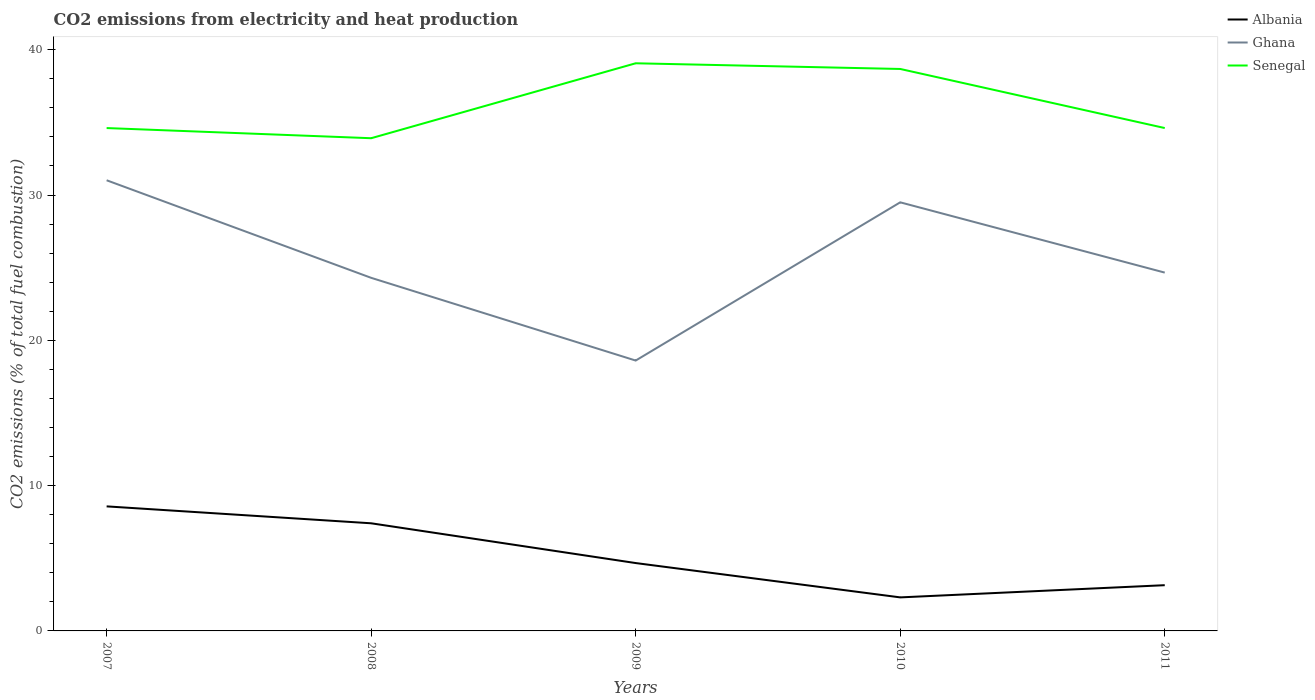How many different coloured lines are there?
Give a very brief answer. 3. Does the line corresponding to Ghana intersect with the line corresponding to Albania?
Give a very brief answer. No. Across all years, what is the maximum amount of CO2 emitted in Albania?
Your response must be concise. 2.31. In which year was the amount of CO2 emitted in Ghana maximum?
Keep it short and to the point. 2009. What is the total amount of CO2 emitted in Ghana in the graph?
Offer a terse response. -6.05. What is the difference between the highest and the second highest amount of CO2 emitted in Albania?
Make the answer very short. 6.26. Is the amount of CO2 emitted in Albania strictly greater than the amount of CO2 emitted in Ghana over the years?
Your answer should be very brief. Yes. What is the difference between two consecutive major ticks on the Y-axis?
Your answer should be very brief. 10. Are the values on the major ticks of Y-axis written in scientific E-notation?
Your answer should be very brief. No. Does the graph contain any zero values?
Your answer should be compact. No. Where does the legend appear in the graph?
Your answer should be very brief. Top right. How are the legend labels stacked?
Make the answer very short. Vertical. What is the title of the graph?
Your answer should be compact. CO2 emissions from electricity and heat production. What is the label or title of the X-axis?
Your answer should be compact. Years. What is the label or title of the Y-axis?
Your answer should be compact. CO2 emissions (% of total fuel combustion). What is the CO2 emissions (% of total fuel combustion) in Albania in 2007?
Ensure brevity in your answer.  8.57. What is the CO2 emissions (% of total fuel combustion) of Ghana in 2007?
Your response must be concise. 31.01. What is the CO2 emissions (% of total fuel combustion) in Senegal in 2007?
Provide a short and direct response. 34.61. What is the CO2 emissions (% of total fuel combustion) in Albania in 2008?
Make the answer very short. 7.41. What is the CO2 emissions (% of total fuel combustion) in Ghana in 2008?
Provide a short and direct response. 24.3. What is the CO2 emissions (% of total fuel combustion) in Senegal in 2008?
Your answer should be very brief. 33.91. What is the CO2 emissions (% of total fuel combustion) of Albania in 2009?
Your answer should be compact. 4.67. What is the CO2 emissions (% of total fuel combustion) in Ghana in 2009?
Provide a succinct answer. 18.61. What is the CO2 emissions (% of total fuel combustion) of Senegal in 2009?
Provide a short and direct response. 39.07. What is the CO2 emissions (% of total fuel combustion) of Albania in 2010?
Your response must be concise. 2.31. What is the CO2 emissions (% of total fuel combustion) in Ghana in 2010?
Make the answer very short. 29.5. What is the CO2 emissions (% of total fuel combustion) in Senegal in 2010?
Ensure brevity in your answer.  38.67. What is the CO2 emissions (% of total fuel combustion) of Albania in 2011?
Make the answer very short. 3.15. What is the CO2 emissions (% of total fuel combustion) in Ghana in 2011?
Give a very brief answer. 24.66. What is the CO2 emissions (% of total fuel combustion) of Senegal in 2011?
Make the answer very short. 34.61. Across all years, what is the maximum CO2 emissions (% of total fuel combustion) of Albania?
Your answer should be very brief. 8.57. Across all years, what is the maximum CO2 emissions (% of total fuel combustion) of Ghana?
Your response must be concise. 31.01. Across all years, what is the maximum CO2 emissions (% of total fuel combustion) of Senegal?
Your response must be concise. 39.07. Across all years, what is the minimum CO2 emissions (% of total fuel combustion) of Albania?
Your response must be concise. 2.31. Across all years, what is the minimum CO2 emissions (% of total fuel combustion) in Ghana?
Give a very brief answer. 18.61. Across all years, what is the minimum CO2 emissions (% of total fuel combustion) of Senegal?
Your response must be concise. 33.91. What is the total CO2 emissions (% of total fuel combustion) of Albania in the graph?
Ensure brevity in your answer.  26.1. What is the total CO2 emissions (% of total fuel combustion) of Ghana in the graph?
Keep it short and to the point. 128.08. What is the total CO2 emissions (% of total fuel combustion) of Senegal in the graph?
Offer a very short reply. 180.86. What is the difference between the CO2 emissions (% of total fuel combustion) of Albania in 2007 and that in 2008?
Offer a terse response. 1.16. What is the difference between the CO2 emissions (% of total fuel combustion) of Ghana in 2007 and that in 2008?
Offer a very short reply. 6.71. What is the difference between the CO2 emissions (% of total fuel combustion) in Senegal in 2007 and that in 2008?
Provide a succinct answer. 0.7. What is the difference between the CO2 emissions (% of total fuel combustion) in Albania in 2007 and that in 2009?
Make the answer very short. 3.9. What is the difference between the CO2 emissions (% of total fuel combustion) in Ghana in 2007 and that in 2009?
Provide a succinct answer. 12.41. What is the difference between the CO2 emissions (% of total fuel combustion) in Senegal in 2007 and that in 2009?
Give a very brief answer. -4.46. What is the difference between the CO2 emissions (% of total fuel combustion) of Albania in 2007 and that in 2010?
Keep it short and to the point. 6.26. What is the difference between the CO2 emissions (% of total fuel combustion) in Ghana in 2007 and that in 2010?
Your response must be concise. 1.52. What is the difference between the CO2 emissions (% of total fuel combustion) of Senegal in 2007 and that in 2010?
Provide a succinct answer. -4.07. What is the difference between the CO2 emissions (% of total fuel combustion) of Albania in 2007 and that in 2011?
Give a very brief answer. 5.42. What is the difference between the CO2 emissions (% of total fuel combustion) of Ghana in 2007 and that in 2011?
Your response must be concise. 6.35. What is the difference between the CO2 emissions (% of total fuel combustion) in Senegal in 2007 and that in 2011?
Offer a very short reply. -0. What is the difference between the CO2 emissions (% of total fuel combustion) of Albania in 2008 and that in 2009?
Your response must be concise. 2.74. What is the difference between the CO2 emissions (% of total fuel combustion) of Ghana in 2008 and that in 2009?
Give a very brief answer. 5.69. What is the difference between the CO2 emissions (% of total fuel combustion) of Senegal in 2008 and that in 2009?
Provide a short and direct response. -5.16. What is the difference between the CO2 emissions (% of total fuel combustion) of Albania in 2008 and that in 2010?
Offer a terse response. 5.1. What is the difference between the CO2 emissions (% of total fuel combustion) of Ghana in 2008 and that in 2010?
Provide a short and direct response. -5.2. What is the difference between the CO2 emissions (% of total fuel combustion) in Senegal in 2008 and that in 2010?
Offer a terse response. -4.77. What is the difference between the CO2 emissions (% of total fuel combustion) of Albania in 2008 and that in 2011?
Provide a succinct answer. 4.26. What is the difference between the CO2 emissions (% of total fuel combustion) of Ghana in 2008 and that in 2011?
Make the answer very short. -0.36. What is the difference between the CO2 emissions (% of total fuel combustion) in Senegal in 2008 and that in 2011?
Make the answer very short. -0.7. What is the difference between the CO2 emissions (% of total fuel combustion) of Albania in 2009 and that in 2010?
Ensure brevity in your answer.  2.36. What is the difference between the CO2 emissions (% of total fuel combustion) of Ghana in 2009 and that in 2010?
Your answer should be very brief. -10.89. What is the difference between the CO2 emissions (% of total fuel combustion) in Senegal in 2009 and that in 2010?
Give a very brief answer. 0.39. What is the difference between the CO2 emissions (% of total fuel combustion) in Albania in 2009 and that in 2011?
Ensure brevity in your answer.  1.52. What is the difference between the CO2 emissions (% of total fuel combustion) in Ghana in 2009 and that in 2011?
Provide a short and direct response. -6.05. What is the difference between the CO2 emissions (% of total fuel combustion) in Senegal in 2009 and that in 2011?
Offer a very short reply. 4.46. What is the difference between the CO2 emissions (% of total fuel combustion) in Albania in 2010 and that in 2011?
Offer a very short reply. -0.84. What is the difference between the CO2 emissions (% of total fuel combustion) in Ghana in 2010 and that in 2011?
Your response must be concise. 4.84. What is the difference between the CO2 emissions (% of total fuel combustion) of Senegal in 2010 and that in 2011?
Make the answer very short. 4.07. What is the difference between the CO2 emissions (% of total fuel combustion) of Albania in 2007 and the CO2 emissions (% of total fuel combustion) of Ghana in 2008?
Offer a very short reply. -15.73. What is the difference between the CO2 emissions (% of total fuel combustion) in Albania in 2007 and the CO2 emissions (% of total fuel combustion) in Senegal in 2008?
Offer a terse response. -25.34. What is the difference between the CO2 emissions (% of total fuel combustion) of Ghana in 2007 and the CO2 emissions (% of total fuel combustion) of Senegal in 2008?
Make the answer very short. -2.89. What is the difference between the CO2 emissions (% of total fuel combustion) in Albania in 2007 and the CO2 emissions (% of total fuel combustion) in Ghana in 2009?
Give a very brief answer. -10.04. What is the difference between the CO2 emissions (% of total fuel combustion) in Albania in 2007 and the CO2 emissions (% of total fuel combustion) in Senegal in 2009?
Give a very brief answer. -30.49. What is the difference between the CO2 emissions (% of total fuel combustion) of Ghana in 2007 and the CO2 emissions (% of total fuel combustion) of Senegal in 2009?
Keep it short and to the point. -8.05. What is the difference between the CO2 emissions (% of total fuel combustion) of Albania in 2007 and the CO2 emissions (% of total fuel combustion) of Ghana in 2010?
Your answer should be very brief. -20.92. What is the difference between the CO2 emissions (% of total fuel combustion) of Albania in 2007 and the CO2 emissions (% of total fuel combustion) of Senegal in 2010?
Your response must be concise. -30.1. What is the difference between the CO2 emissions (% of total fuel combustion) in Ghana in 2007 and the CO2 emissions (% of total fuel combustion) in Senegal in 2010?
Give a very brief answer. -7.66. What is the difference between the CO2 emissions (% of total fuel combustion) of Albania in 2007 and the CO2 emissions (% of total fuel combustion) of Ghana in 2011?
Provide a short and direct response. -16.09. What is the difference between the CO2 emissions (% of total fuel combustion) of Albania in 2007 and the CO2 emissions (% of total fuel combustion) of Senegal in 2011?
Offer a terse response. -26.04. What is the difference between the CO2 emissions (% of total fuel combustion) of Ghana in 2007 and the CO2 emissions (% of total fuel combustion) of Senegal in 2011?
Offer a terse response. -3.59. What is the difference between the CO2 emissions (% of total fuel combustion) in Albania in 2008 and the CO2 emissions (% of total fuel combustion) in Ghana in 2009?
Give a very brief answer. -11.2. What is the difference between the CO2 emissions (% of total fuel combustion) of Albania in 2008 and the CO2 emissions (% of total fuel combustion) of Senegal in 2009?
Offer a very short reply. -31.66. What is the difference between the CO2 emissions (% of total fuel combustion) of Ghana in 2008 and the CO2 emissions (% of total fuel combustion) of Senegal in 2009?
Your answer should be compact. -14.77. What is the difference between the CO2 emissions (% of total fuel combustion) in Albania in 2008 and the CO2 emissions (% of total fuel combustion) in Ghana in 2010?
Keep it short and to the point. -22.09. What is the difference between the CO2 emissions (% of total fuel combustion) of Albania in 2008 and the CO2 emissions (% of total fuel combustion) of Senegal in 2010?
Give a very brief answer. -31.27. What is the difference between the CO2 emissions (% of total fuel combustion) in Ghana in 2008 and the CO2 emissions (% of total fuel combustion) in Senegal in 2010?
Ensure brevity in your answer.  -14.37. What is the difference between the CO2 emissions (% of total fuel combustion) in Albania in 2008 and the CO2 emissions (% of total fuel combustion) in Ghana in 2011?
Make the answer very short. -17.25. What is the difference between the CO2 emissions (% of total fuel combustion) in Albania in 2008 and the CO2 emissions (% of total fuel combustion) in Senegal in 2011?
Give a very brief answer. -27.2. What is the difference between the CO2 emissions (% of total fuel combustion) of Ghana in 2008 and the CO2 emissions (% of total fuel combustion) of Senegal in 2011?
Provide a succinct answer. -10.31. What is the difference between the CO2 emissions (% of total fuel combustion) of Albania in 2009 and the CO2 emissions (% of total fuel combustion) of Ghana in 2010?
Your response must be concise. -24.83. What is the difference between the CO2 emissions (% of total fuel combustion) in Albania in 2009 and the CO2 emissions (% of total fuel combustion) in Senegal in 2010?
Keep it short and to the point. -34. What is the difference between the CO2 emissions (% of total fuel combustion) in Ghana in 2009 and the CO2 emissions (% of total fuel combustion) in Senegal in 2010?
Offer a terse response. -20.07. What is the difference between the CO2 emissions (% of total fuel combustion) of Albania in 2009 and the CO2 emissions (% of total fuel combustion) of Ghana in 2011?
Offer a very short reply. -19.99. What is the difference between the CO2 emissions (% of total fuel combustion) of Albania in 2009 and the CO2 emissions (% of total fuel combustion) of Senegal in 2011?
Give a very brief answer. -29.94. What is the difference between the CO2 emissions (% of total fuel combustion) in Ghana in 2009 and the CO2 emissions (% of total fuel combustion) in Senegal in 2011?
Offer a terse response. -16. What is the difference between the CO2 emissions (% of total fuel combustion) of Albania in 2010 and the CO2 emissions (% of total fuel combustion) of Ghana in 2011?
Your answer should be compact. -22.35. What is the difference between the CO2 emissions (% of total fuel combustion) of Albania in 2010 and the CO2 emissions (% of total fuel combustion) of Senegal in 2011?
Offer a terse response. -32.3. What is the difference between the CO2 emissions (% of total fuel combustion) in Ghana in 2010 and the CO2 emissions (% of total fuel combustion) in Senegal in 2011?
Provide a short and direct response. -5.11. What is the average CO2 emissions (% of total fuel combustion) of Albania per year?
Your answer should be very brief. 5.22. What is the average CO2 emissions (% of total fuel combustion) in Ghana per year?
Your answer should be compact. 25.62. What is the average CO2 emissions (% of total fuel combustion) in Senegal per year?
Provide a short and direct response. 36.17. In the year 2007, what is the difference between the CO2 emissions (% of total fuel combustion) in Albania and CO2 emissions (% of total fuel combustion) in Ghana?
Provide a short and direct response. -22.44. In the year 2007, what is the difference between the CO2 emissions (% of total fuel combustion) of Albania and CO2 emissions (% of total fuel combustion) of Senegal?
Offer a very short reply. -26.04. In the year 2007, what is the difference between the CO2 emissions (% of total fuel combustion) in Ghana and CO2 emissions (% of total fuel combustion) in Senegal?
Your answer should be compact. -3.59. In the year 2008, what is the difference between the CO2 emissions (% of total fuel combustion) of Albania and CO2 emissions (% of total fuel combustion) of Ghana?
Ensure brevity in your answer.  -16.89. In the year 2008, what is the difference between the CO2 emissions (% of total fuel combustion) in Albania and CO2 emissions (% of total fuel combustion) in Senegal?
Your answer should be very brief. -26.5. In the year 2008, what is the difference between the CO2 emissions (% of total fuel combustion) of Ghana and CO2 emissions (% of total fuel combustion) of Senegal?
Provide a succinct answer. -9.61. In the year 2009, what is the difference between the CO2 emissions (% of total fuel combustion) in Albania and CO2 emissions (% of total fuel combustion) in Ghana?
Offer a very short reply. -13.94. In the year 2009, what is the difference between the CO2 emissions (% of total fuel combustion) of Albania and CO2 emissions (% of total fuel combustion) of Senegal?
Keep it short and to the point. -34.4. In the year 2009, what is the difference between the CO2 emissions (% of total fuel combustion) of Ghana and CO2 emissions (% of total fuel combustion) of Senegal?
Your response must be concise. -20.46. In the year 2010, what is the difference between the CO2 emissions (% of total fuel combustion) of Albania and CO2 emissions (% of total fuel combustion) of Ghana?
Your answer should be very brief. -27.19. In the year 2010, what is the difference between the CO2 emissions (% of total fuel combustion) of Albania and CO2 emissions (% of total fuel combustion) of Senegal?
Ensure brevity in your answer.  -36.37. In the year 2010, what is the difference between the CO2 emissions (% of total fuel combustion) of Ghana and CO2 emissions (% of total fuel combustion) of Senegal?
Your response must be concise. -9.18. In the year 2011, what is the difference between the CO2 emissions (% of total fuel combustion) in Albania and CO2 emissions (% of total fuel combustion) in Ghana?
Offer a very short reply. -21.51. In the year 2011, what is the difference between the CO2 emissions (% of total fuel combustion) in Albania and CO2 emissions (% of total fuel combustion) in Senegal?
Provide a succinct answer. -31.46. In the year 2011, what is the difference between the CO2 emissions (% of total fuel combustion) of Ghana and CO2 emissions (% of total fuel combustion) of Senegal?
Your answer should be very brief. -9.95. What is the ratio of the CO2 emissions (% of total fuel combustion) of Albania in 2007 to that in 2008?
Keep it short and to the point. 1.16. What is the ratio of the CO2 emissions (% of total fuel combustion) in Ghana in 2007 to that in 2008?
Give a very brief answer. 1.28. What is the ratio of the CO2 emissions (% of total fuel combustion) in Senegal in 2007 to that in 2008?
Provide a short and direct response. 1.02. What is the ratio of the CO2 emissions (% of total fuel combustion) in Albania in 2007 to that in 2009?
Your answer should be very brief. 1.84. What is the ratio of the CO2 emissions (% of total fuel combustion) in Ghana in 2007 to that in 2009?
Your answer should be very brief. 1.67. What is the ratio of the CO2 emissions (% of total fuel combustion) in Senegal in 2007 to that in 2009?
Provide a succinct answer. 0.89. What is the ratio of the CO2 emissions (% of total fuel combustion) in Albania in 2007 to that in 2010?
Offer a very short reply. 3.71. What is the ratio of the CO2 emissions (% of total fuel combustion) of Ghana in 2007 to that in 2010?
Give a very brief answer. 1.05. What is the ratio of the CO2 emissions (% of total fuel combustion) of Senegal in 2007 to that in 2010?
Offer a very short reply. 0.89. What is the ratio of the CO2 emissions (% of total fuel combustion) in Albania in 2007 to that in 2011?
Offer a terse response. 2.72. What is the ratio of the CO2 emissions (% of total fuel combustion) of Ghana in 2007 to that in 2011?
Give a very brief answer. 1.26. What is the ratio of the CO2 emissions (% of total fuel combustion) in Senegal in 2007 to that in 2011?
Make the answer very short. 1. What is the ratio of the CO2 emissions (% of total fuel combustion) in Albania in 2008 to that in 2009?
Ensure brevity in your answer.  1.59. What is the ratio of the CO2 emissions (% of total fuel combustion) in Ghana in 2008 to that in 2009?
Your response must be concise. 1.31. What is the ratio of the CO2 emissions (% of total fuel combustion) in Senegal in 2008 to that in 2009?
Ensure brevity in your answer.  0.87. What is the ratio of the CO2 emissions (% of total fuel combustion) in Albania in 2008 to that in 2010?
Your answer should be compact. 3.21. What is the ratio of the CO2 emissions (% of total fuel combustion) of Ghana in 2008 to that in 2010?
Offer a terse response. 0.82. What is the ratio of the CO2 emissions (% of total fuel combustion) in Senegal in 2008 to that in 2010?
Provide a short and direct response. 0.88. What is the ratio of the CO2 emissions (% of total fuel combustion) in Albania in 2008 to that in 2011?
Ensure brevity in your answer.  2.35. What is the ratio of the CO2 emissions (% of total fuel combustion) of Ghana in 2008 to that in 2011?
Provide a succinct answer. 0.99. What is the ratio of the CO2 emissions (% of total fuel combustion) in Senegal in 2008 to that in 2011?
Offer a very short reply. 0.98. What is the ratio of the CO2 emissions (% of total fuel combustion) in Albania in 2009 to that in 2010?
Your answer should be compact. 2.02. What is the ratio of the CO2 emissions (% of total fuel combustion) in Ghana in 2009 to that in 2010?
Offer a terse response. 0.63. What is the ratio of the CO2 emissions (% of total fuel combustion) of Senegal in 2009 to that in 2010?
Offer a terse response. 1.01. What is the ratio of the CO2 emissions (% of total fuel combustion) in Albania in 2009 to that in 2011?
Offer a very short reply. 1.48. What is the ratio of the CO2 emissions (% of total fuel combustion) in Ghana in 2009 to that in 2011?
Keep it short and to the point. 0.75. What is the ratio of the CO2 emissions (% of total fuel combustion) in Senegal in 2009 to that in 2011?
Give a very brief answer. 1.13. What is the ratio of the CO2 emissions (% of total fuel combustion) in Albania in 2010 to that in 2011?
Provide a succinct answer. 0.73. What is the ratio of the CO2 emissions (% of total fuel combustion) in Ghana in 2010 to that in 2011?
Offer a very short reply. 1.2. What is the ratio of the CO2 emissions (% of total fuel combustion) in Senegal in 2010 to that in 2011?
Provide a succinct answer. 1.12. What is the difference between the highest and the second highest CO2 emissions (% of total fuel combustion) of Albania?
Offer a very short reply. 1.16. What is the difference between the highest and the second highest CO2 emissions (% of total fuel combustion) in Ghana?
Provide a short and direct response. 1.52. What is the difference between the highest and the second highest CO2 emissions (% of total fuel combustion) of Senegal?
Provide a succinct answer. 0.39. What is the difference between the highest and the lowest CO2 emissions (% of total fuel combustion) in Albania?
Make the answer very short. 6.26. What is the difference between the highest and the lowest CO2 emissions (% of total fuel combustion) of Ghana?
Your answer should be compact. 12.41. What is the difference between the highest and the lowest CO2 emissions (% of total fuel combustion) in Senegal?
Offer a very short reply. 5.16. 